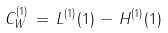Convert formula to latex. <formula><loc_0><loc_0><loc_500><loc_500>C _ { W } ^ { ( 1 ) } \, = \, L ^ { ( 1 ) } ( 1 ) \, - \, H ^ { ( 1 ) } ( 1 )</formula> 